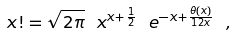<formula> <loc_0><loc_0><loc_500><loc_500>x ! = \sqrt { 2 \pi } \ x ^ { x + \frac { 1 } { 2 } } \ e ^ { - x + \frac { \theta ( x ) } { 1 2 x } } \ ,</formula> 